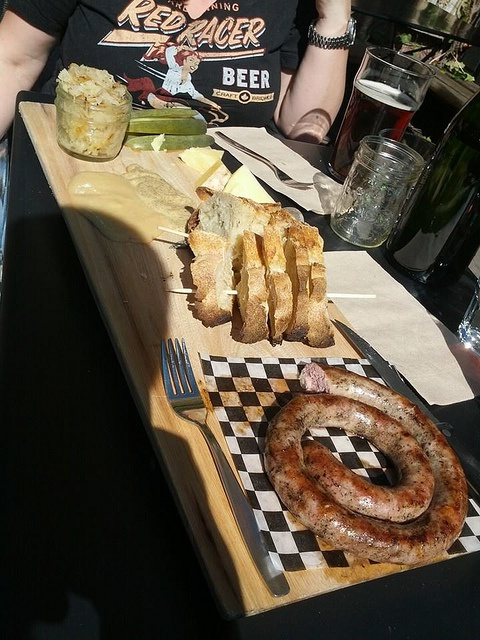Describe the objects in this image and their specific colors. I can see dining table in black, tan, maroon, and beige tones, people in black, tan, and darkgray tones, hot dog in black, maroon, and gray tones, cup in black, gray, and darkgray tones, and cup in black, gray, darkgray, and maroon tones in this image. 